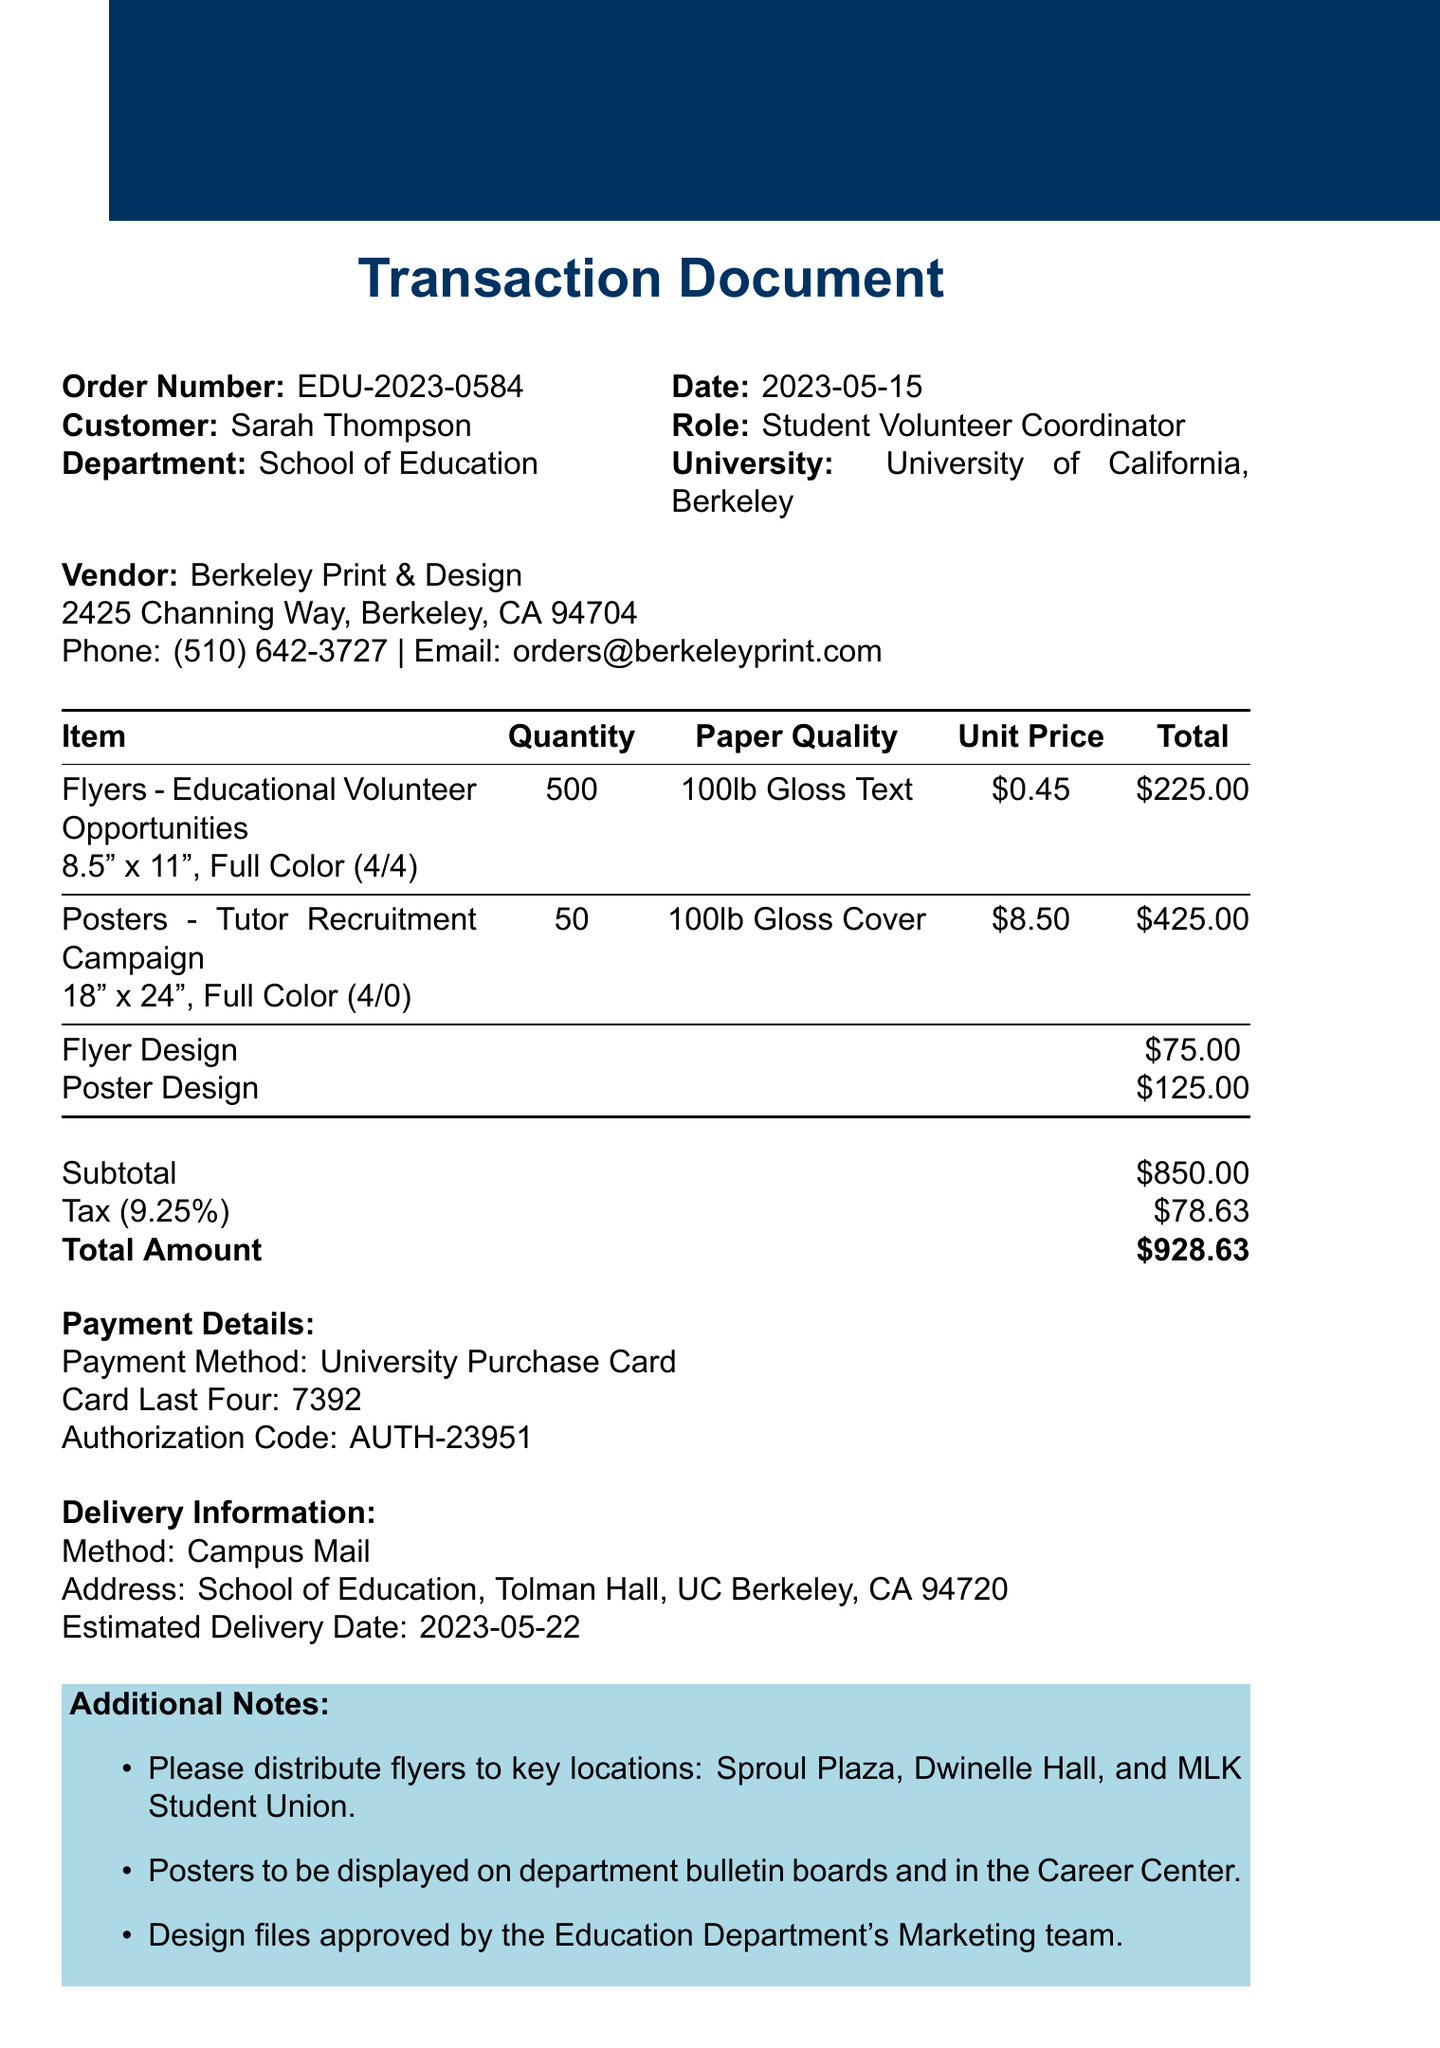What is the order number? The order number is specified in the transaction details section of the document.
Answer: EDU-2023-0584 Who is the customer? The customer's name is provided in the transaction details.
Answer: Sarah Thompson What is the unit price of the posters? The unit price for the posters is listed in the items section.
Answer: $8.50 What is the total amount due? The total amount due is shown in the payment details section, which includes subtotal and tax.
Answer: $928.63 How many flyers are ordered? The quantity of flyers ordered is specified in the items section of the document.
Answer: 500 What is the delivery method? The delivery method is indicated in the delivery information section.
Answer: Campus Mail What is the design charge for the flyers? The design charge for the flyers can be found in the design charges section of the document.
Answer: $75.00 Which department is associated with the customer? The customer’s department is mentioned in the transaction details.
Answer: School of Education What is the estimated delivery date? This information is provided in the delivery information section of the document.
Answer: 2023-05-22 